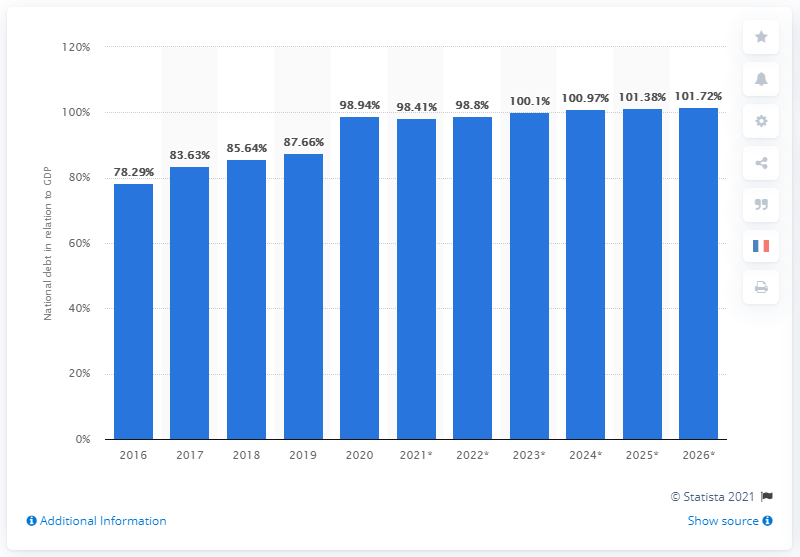Outline some significant characteristics in this image. In 2020, the national debt of Brazil accounted for approximately 98.8% of the country's Gross Domestic Product (GDP). 